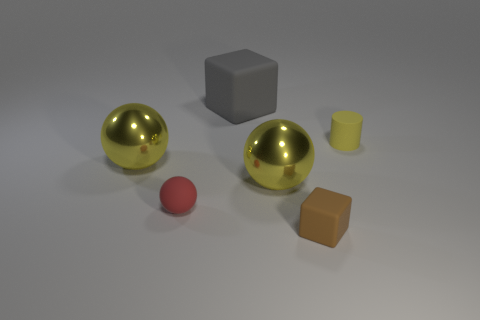There is a matte cube that is in front of the cube behind the tiny brown thing; what color is it?
Ensure brevity in your answer.  Brown. How many things are large cubes or shiny spheres that are to the right of the big rubber thing?
Give a very brief answer. 2. Is there a large shiny thing that has the same color as the cylinder?
Keep it short and to the point. Yes. How many brown objects are either large matte cubes or large shiny spheres?
Ensure brevity in your answer.  0. How many big objects are yellow rubber cylinders or metallic spheres?
Offer a very short reply. 2. Does the red matte object have the same size as the cube that is behind the red thing?
Your answer should be very brief. No. What number of other objects are the same shape as the red rubber object?
Offer a very short reply. 2. What is the shape of the yellow thing that is the same material as the gray block?
Offer a very short reply. Cylinder. Are any tiny cyan balls visible?
Keep it short and to the point. No. Are there fewer small rubber blocks to the right of the tiny cube than matte objects behind the yellow matte thing?
Offer a very short reply. Yes. 